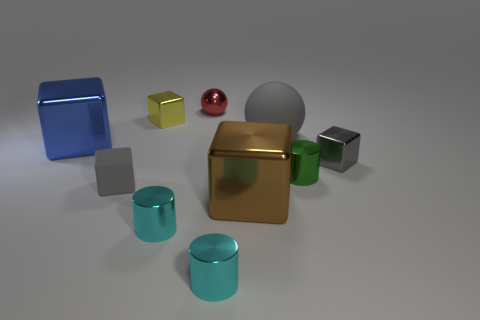How many red shiny objects are there?
Keep it short and to the point. 1. Does the green cylinder have the same size as the yellow shiny block?
Your answer should be compact. Yes. Is there a large matte cube that has the same color as the rubber sphere?
Your response must be concise. No. There is a small gray object that is right of the metal ball; is it the same shape as the yellow metal object?
Your response must be concise. Yes. How many objects are the same size as the blue cube?
Your response must be concise. 2. How many tiny gray matte cubes are on the right side of the small cyan cylinder that is on the right side of the tiny red object?
Ensure brevity in your answer.  0. Is the sphere in front of the tiny yellow shiny object made of the same material as the small yellow cube?
Provide a short and direct response. No. Does the large brown cube right of the gray matte block have the same material as the gray thing that is on the left side of the big gray thing?
Offer a terse response. No. Are there more small gray rubber things right of the rubber ball than tiny metallic spheres?
Provide a short and direct response. No. The cube that is to the right of the big metallic block right of the tiny metallic ball is what color?
Keep it short and to the point. Gray. 